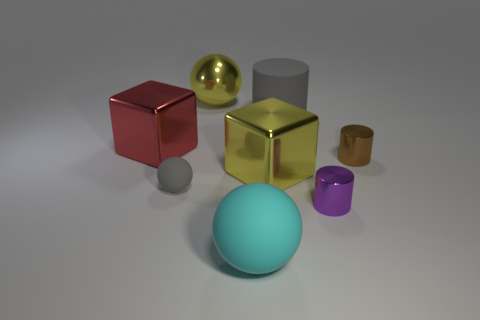What materials seem to be represented by the different objects in the image? The image displays objects that appear to be made from various materials. The sphere in the front looks like it could be made of a matte plastic, the cube on the left seems like it's a shiny metal, possibly reflecting a red hue, indicating a metallic paint or coating. The cylinder on the back seems to be a brushed metal, while the small cup in front of it appears to be gold or brass. The small cylinder to the right seems ceramic, given its matte, slightly reflective surface. 